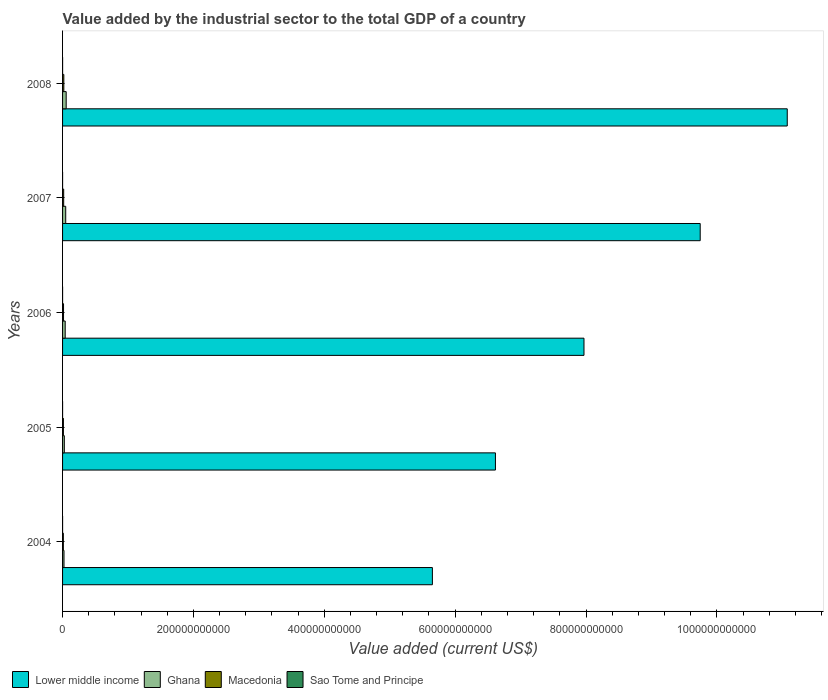Are the number of bars per tick equal to the number of legend labels?
Keep it short and to the point. Yes. How many bars are there on the 4th tick from the top?
Ensure brevity in your answer.  4. How many bars are there on the 4th tick from the bottom?
Ensure brevity in your answer.  4. What is the label of the 3rd group of bars from the top?
Make the answer very short. 2006. In how many cases, is the number of bars for a given year not equal to the number of legend labels?
Your response must be concise. 0. What is the value added by the industrial sector to the total GDP in Macedonia in 2006?
Offer a very short reply. 1.49e+09. Across all years, what is the maximum value added by the industrial sector to the total GDP in Ghana?
Make the answer very short. 5.53e+09. Across all years, what is the minimum value added by the industrial sector to the total GDP in Ghana?
Offer a very short reply. 2.20e+09. What is the total value added by the industrial sector to the total GDP in Ghana in the graph?
Make the answer very short. 1.93e+1. What is the difference between the value added by the industrial sector to the total GDP in Lower middle income in 2004 and that in 2007?
Your answer should be very brief. -4.09e+11. What is the difference between the value added by the industrial sector to the total GDP in Lower middle income in 2004 and the value added by the industrial sector to the total GDP in Macedonia in 2007?
Provide a short and direct response. 5.63e+11. What is the average value added by the industrial sector to the total GDP in Sao Tome and Principe per year?
Provide a short and direct response. 2.18e+07. In the year 2005, what is the difference between the value added by the industrial sector to the total GDP in Ghana and value added by the industrial sector to the total GDP in Macedonia?
Keep it short and to the point. 1.42e+09. What is the ratio of the value added by the industrial sector to the total GDP in Lower middle income in 2005 to that in 2006?
Give a very brief answer. 0.83. Is the value added by the industrial sector to the total GDP in Sao Tome and Principe in 2004 less than that in 2008?
Keep it short and to the point. Yes. Is the difference between the value added by the industrial sector to the total GDP in Ghana in 2005 and 2008 greater than the difference between the value added by the industrial sector to the total GDP in Macedonia in 2005 and 2008?
Make the answer very short. No. What is the difference between the highest and the second highest value added by the industrial sector to the total GDP in Sao Tome and Principe?
Provide a succinct answer. 1.04e+07. What is the difference between the highest and the lowest value added by the industrial sector to the total GDP in Macedonia?
Provide a short and direct response. 7.40e+08. Is the sum of the value added by the industrial sector to the total GDP in Macedonia in 2005 and 2006 greater than the maximum value added by the industrial sector to the total GDP in Ghana across all years?
Offer a terse response. No. Is it the case that in every year, the sum of the value added by the industrial sector to the total GDP in Lower middle income and value added by the industrial sector to the total GDP in Sao Tome and Principe is greater than the sum of value added by the industrial sector to the total GDP in Ghana and value added by the industrial sector to the total GDP in Macedonia?
Offer a terse response. Yes. What does the 1st bar from the top in 2006 represents?
Ensure brevity in your answer.  Sao Tome and Principe. What does the 1st bar from the bottom in 2005 represents?
Your answer should be very brief. Lower middle income. Is it the case that in every year, the sum of the value added by the industrial sector to the total GDP in Lower middle income and value added by the industrial sector to the total GDP in Macedonia is greater than the value added by the industrial sector to the total GDP in Sao Tome and Principe?
Your answer should be compact. Yes. What is the difference between two consecutive major ticks on the X-axis?
Provide a succinct answer. 2.00e+11. Are the values on the major ticks of X-axis written in scientific E-notation?
Make the answer very short. No. Does the graph contain any zero values?
Offer a terse response. No. Does the graph contain grids?
Keep it short and to the point. No. How are the legend labels stacked?
Provide a short and direct response. Horizontal. What is the title of the graph?
Your answer should be compact. Value added by the industrial sector to the total GDP of a country. Does "Saudi Arabia" appear as one of the legend labels in the graph?
Provide a succinct answer. No. What is the label or title of the X-axis?
Your answer should be very brief. Value added (current US$). What is the label or title of the Y-axis?
Your answer should be compact. Years. What is the Value added (current US$) of Lower middle income in 2004?
Offer a terse response. 5.65e+11. What is the Value added (current US$) of Ghana in 2004?
Keep it short and to the point. 2.20e+09. What is the Value added (current US$) in Macedonia in 2004?
Ensure brevity in your answer.  1.20e+09. What is the Value added (current US$) in Sao Tome and Principe in 2004?
Ensure brevity in your answer.  1.64e+07. What is the Value added (current US$) in Lower middle income in 2005?
Offer a terse response. 6.62e+11. What is the Value added (current US$) of Ghana in 2005?
Provide a short and direct response. 2.70e+09. What is the Value added (current US$) of Macedonia in 2005?
Your response must be concise. 1.27e+09. What is the Value added (current US$) in Sao Tome and Principe in 2005?
Your answer should be compact. 1.89e+07. What is the Value added (current US$) in Lower middle income in 2006?
Ensure brevity in your answer.  7.97e+11. What is the Value added (current US$) of Ghana in 2006?
Keep it short and to the point. 4.04e+09. What is the Value added (current US$) in Macedonia in 2006?
Provide a succinct answer. 1.49e+09. What is the Value added (current US$) of Sao Tome and Principe in 2006?
Your answer should be very brief. 1.98e+07. What is the Value added (current US$) in Lower middle income in 2007?
Provide a short and direct response. 9.75e+11. What is the Value added (current US$) of Ghana in 2007?
Give a very brief answer. 4.83e+09. What is the Value added (current US$) of Macedonia in 2007?
Ensure brevity in your answer.  1.72e+09. What is the Value added (current US$) of Sao Tome and Principe in 2007?
Your response must be concise. 2.17e+07. What is the Value added (current US$) in Lower middle income in 2008?
Offer a terse response. 1.11e+12. What is the Value added (current US$) in Ghana in 2008?
Offer a very short reply. 5.53e+09. What is the Value added (current US$) in Macedonia in 2008?
Ensure brevity in your answer.  1.94e+09. What is the Value added (current US$) of Sao Tome and Principe in 2008?
Your response must be concise. 3.22e+07. Across all years, what is the maximum Value added (current US$) in Lower middle income?
Your answer should be compact. 1.11e+12. Across all years, what is the maximum Value added (current US$) of Ghana?
Offer a terse response. 5.53e+09. Across all years, what is the maximum Value added (current US$) of Macedonia?
Your answer should be compact. 1.94e+09. Across all years, what is the maximum Value added (current US$) of Sao Tome and Principe?
Keep it short and to the point. 3.22e+07. Across all years, what is the minimum Value added (current US$) in Lower middle income?
Your answer should be compact. 5.65e+11. Across all years, what is the minimum Value added (current US$) of Ghana?
Offer a very short reply. 2.20e+09. Across all years, what is the minimum Value added (current US$) of Macedonia?
Make the answer very short. 1.20e+09. Across all years, what is the minimum Value added (current US$) in Sao Tome and Principe?
Offer a terse response. 1.64e+07. What is the total Value added (current US$) in Lower middle income in the graph?
Your response must be concise. 4.11e+12. What is the total Value added (current US$) in Ghana in the graph?
Keep it short and to the point. 1.93e+1. What is the total Value added (current US$) of Macedonia in the graph?
Provide a short and direct response. 7.61e+09. What is the total Value added (current US$) of Sao Tome and Principe in the graph?
Ensure brevity in your answer.  1.09e+08. What is the difference between the Value added (current US$) in Lower middle income in 2004 and that in 2005?
Make the answer very short. -9.64e+1. What is the difference between the Value added (current US$) of Ghana in 2004 and that in 2005?
Your answer should be very brief. -5.01e+08. What is the difference between the Value added (current US$) in Macedonia in 2004 and that in 2005?
Give a very brief answer. -7.88e+07. What is the difference between the Value added (current US$) in Sao Tome and Principe in 2004 and that in 2005?
Your response must be concise. -2.54e+06. What is the difference between the Value added (current US$) in Lower middle income in 2004 and that in 2006?
Provide a short and direct response. -2.32e+11. What is the difference between the Value added (current US$) in Ghana in 2004 and that in 2006?
Your answer should be very brief. -1.85e+09. What is the difference between the Value added (current US$) of Macedonia in 2004 and that in 2006?
Your answer should be very brief. -2.91e+08. What is the difference between the Value added (current US$) in Sao Tome and Principe in 2004 and that in 2006?
Your answer should be very brief. -3.43e+06. What is the difference between the Value added (current US$) of Lower middle income in 2004 and that in 2007?
Offer a terse response. -4.09e+11. What is the difference between the Value added (current US$) of Ghana in 2004 and that in 2007?
Your answer should be very brief. -2.63e+09. What is the difference between the Value added (current US$) in Macedonia in 2004 and that in 2007?
Offer a terse response. -5.20e+08. What is the difference between the Value added (current US$) in Sao Tome and Principe in 2004 and that in 2007?
Give a very brief answer. -5.34e+06. What is the difference between the Value added (current US$) in Lower middle income in 2004 and that in 2008?
Your answer should be compact. -5.42e+11. What is the difference between the Value added (current US$) of Ghana in 2004 and that in 2008?
Provide a short and direct response. -3.34e+09. What is the difference between the Value added (current US$) of Macedonia in 2004 and that in 2008?
Provide a succinct answer. -7.40e+08. What is the difference between the Value added (current US$) in Sao Tome and Principe in 2004 and that in 2008?
Your answer should be very brief. -1.58e+07. What is the difference between the Value added (current US$) in Lower middle income in 2005 and that in 2006?
Provide a succinct answer. -1.35e+11. What is the difference between the Value added (current US$) in Ghana in 2005 and that in 2006?
Provide a succinct answer. -1.35e+09. What is the difference between the Value added (current US$) in Macedonia in 2005 and that in 2006?
Ensure brevity in your answer.  -2.12e+08. What is the difference between the Value added (current US$) of Sao Tome and Principe in 2005 and that in 2006?
Provide a succinct answer. -8.85e+05. What is the difference between the Value added (current US$) of Lower middle income in 2005 and that in 2007?
Your response must be concise. -3.13e+11. What is the difference between the Value added (current US$) in Ghana in 2005 and that in 2007?
Provide a succinct answer. -2.13e+09. What is the difference between the Value added (current US$) in Macedonia in 2005 and that in 2007?
Provide a succinct answer. -4.41e+08. What is the difference between the Value added (current US$) in Sao Tome and Principe in 2005 and that in 2007?
Provide a succinct answer. -2.80e+06. What is the difference between the Value added (current US$) of Lower middle income in 2005 and that in 2008?
Ensure brevity in your answer.  -4.46e+11. What is the difference between the Value added (current US$) of Ghana in 2005 and that in 2008?
Your answer should be very brief. -2.84e+09. What is the difference between the Value added (current US$) in Macedonia in 2005 and that in 2008?
Provide a succinct answer. -6.61e+08. What is the difference between the Value added (current US$) of Sao Tome and Principe in 2005 and that in 2008?
Provide a succinct answer. -1.32e+07. What is the difference between the Value added (current US$) of Lower middle income in 2006 and that in 2007?
Provide a succinct answer. -1.78e+11. What is the difference between the Value added (current US$) in Ghana in 2006 and that in 2007?
Give a very brief answer. -7.84e+08. What is the difference between the Value added (current US$) in Macedonia in 2006 and that in 2007?
Provide a short and direct response. -2.29e+08. What is the difference between the Value added (current US$) in Sao Tome and Principe in 2006 and that in 2007?
Your answer should be very brief. -1.92e+06. What is the difference between the Value added (current US$) of Lower middle income in 2006 and that in 2008?
Keep it short and to the point. -3.11e+11. What is the difference between the Value added (current US$) of Ghana in 2006 and that in 2008?
Your answer should be very brief. -1.49e+09. What is the difference between the Value added (current US$) of Macedonia in 2006 and that in 2008?
Ensure brevity in your answer.  -4.49e+08. What is the difference between the Value added (current US$) of Sao Tome and Principe in 2006 and that in 2008?
Your answer should be compact. -1.24e+07. What is the difference between the Value added (current US$) in Lower middle income in 2007 and that in 2008?
Your answer should be compact. -1.33e+11. What is the difference between the Value added (current US$) in Ghana in 2007 and that in 2008?
Provide a succinct answer. -7.08e+08. What is the difference between the Value added (current US$) of Macedonia in 2007 and that in 2008?
Give a very brief answer. -2.20e+08. What is the difference between the Value added (current US$) in Sao Tome and Principe in 2007 and that in 2008?
Ensure brevity in your answer.  -1.04e+07. What is the difference between the Value added (current US$) in Lower middle income in 2004 and the Value added (current US$) in Ghana in 2005?
Your answer should be very brief. 5.63e+11. What is the difference between the Value added (current US$) in Lower middle income in 2004 and the Value added (current US$) in Macedonia in 2005?
Your answer should be compact. 5.64e+11. What is the difference between the Value added (current US$) of Lower middle income in 2004 and the Value added (current US$) of Sao Tome and Principe in 2005?
Provide a short and direct response. 5.65e+11. What is the difference between the Value added (current US$) of Ghana in 2004 and the Value added (current US$) of Macedonia in 2005?
Provide a short and direct response. 9.21e+08. What is the difference between the Value added (current US$) in Ghana in 2004 and the Value added (current US$) in Sao Tome and Principe in 2005?
Your answer should be very brief. 2.18e+09. What is the difference between the Value added (current US$) of Macedonia in 2004 and the Value added (current US$) of Sao Tome and Principe in 2005?
Provide a succinct answer. 1.18e+09. What is the difference between the Value added (current US$) of Lower middle income in 2004 and the Value added (current US$) of Ghana in 2006?
Keep it short and to the point. 5.61e+11. What is the difference between the Value added (current US$) of Lower middle income in 2004 and the Value added (current US$) of Macedonia in 2006?
Your response must be concise. 5.64e+11. What is the difference between the Value added (current US$) of Lower middle income in 2004 and the Value added (current US$) of Sao Tome and Principe in 2006?
Give a very brief answer. 5.65e+11. What is the difference between the Value added (current US$) of Ghana in 2004 and the Value added (current US$) of Macedonia in 2006?
Offer a terse response. 7.09e+08. What is the difference between the Value added (current US$) in Ghana in 2004 and the Value added (current US$) in Sao Tome and Principe in 2006?
Provide a short and direct response. 2.18e+09. What is the difference between the Value added (current US$) in Macedonia in 2004 and the Value added (current US$) in Sao Tome and Principe in 2006?
Give a very brief answer. 1.18e+09. What is the difference between the Value added (current US$) of Lower middle income in 2004 and the Value added (current US$) of Ghana in 2007?
Your response must be concise. 5.60e+11. What is the difference between the Value added (current US$) of Lower middle income in 2004 and the Value added (current US$) of Macedonia in 2007?
Provide a short and direct response. 5.63e+11. What is the difference between the Value added (current US$) in Lower middle income in 2004 and the Value added (current US$) in Sao Tome and Principe in 2007?
Offer a terse response. 5.65e+11. What is the difference between the Value added (current US$) in Ghana in 2004 and the Value added (current US$) in Macedonia in 2007?
Make the answer very short. 4.79e+08. What is the difference between the Value added (current US$) of Ghana in 2004 and the Value added (current US$) of Sao Tome and Principe in 2007?
Offer a very short reply. 2.17e+09. What is the difference between the Value added (current US$) of Macedonia in 2004 and the Value added (current US$) of Sao Tome and Principe in 2007?
Offer a very short reply. 1.17e+09. What is the difference between the Value added (current US$) of Lower middle income in 2004 and the Value added (current US$) of Ghana in 2008?
Offer a very short reply. 5.60e+11. What is the difference between the Value added (current US$) of Lower middle income in 2004 and the Value added (current US$) of Macedonia in 2008?
Ensure brevity in your answer.  5.63e+11. What is the difference between the Value added (current US$) of Lower middle income in 2004 and the Value added (current US$) of Sao Tome and Principe in 2008?
Give a very brief answer. 5.65e+11. What is the difference between the Value added (current US$) of Ghana in 2004 and the Value added (current US$) of Macedonia in 2008?
Offer a very short reply. 2.60e+08. What is the difference between the Value added (current US$) in Ghana in 2004 and the Value added (current US$) in Sao Tome and Principe in 2008?
Ensure brevity in your answer.  2.16e+09. What is the difference between the Value added (current US$) in Macedonia in 2004 and the Value added (current US$) in Sao Tome and Principe in 2008?
Make the answer very short. 1.16e+09. What is the difference between the Value added (current US$) in Lower middle income in 2005 and the Value added (current US$) in Ghana in 2006?
Your answer should be compact. 6.58e+11. What is the difference between the Value added (current US$) in Lower middle income in 2005 and the Value added (current US$) in Macedonia in 2006?
Give a very brief answer. 6.60e+11. What is the difference between the Value added (current US$) in Lower middle income in 2005 and the Value added (current US$) in Sao Tome and Principe in 2006?
Provide a short and direct response. 6.62e+11. What is the difference between the Value added (current US$) of Ghana in 2005 and the Value added (current US$) of Macedonia in 2006?
Offer a very short reply. 1.21e+09. What is the difference between the Value added (current US$) in Ghana in 2005 and the Value added (current US$) in Sao Tome and Principe in 2006?
Keep it short and to the point. 2.68e+09. What is the difference between the Value added (current US$) in Macedonia in 2005 and the Value added (current US$) in Sao Tome and Principe in 2006?
Your answer should be very brief. 1.25e+09. What is the difference between the Value added (current US$) in Lower middle income in 2005 and the Value added (current US$) in Ghana in 2007?
Your response must be concise. 6.57e+11. What is the difference between the Value added (current US$) of Lower middle income in 2005 and the Value added (current US$) of Macedonia in 2007?
Make the answer very short. 6.60e+11. What is the difference between the Value added (current US$) of Lower middle income in 2005 and the Value added (current US$) of Sao Tome and Principe in 2007?
Offer a terse response. 6.62e+11. What is the difference between the Value added (current US$) in Ghana in 2005 and the Value added (current US$) in Macedonia in 2007?
Ensure brevity in your answer.  9.81e+08. What is the difference between the Value added (current US$) in Ghana in 2005 and the Value added (current US$) in Sao Tome and Principe in 2007?
Ensure brevity in your answer.  2.67e+09. What is the difference between the Value added (current US$) in Macedonia in 2005 and the Value added (current US$) in Sao Tome and Principe in 2007?
Your answer should be very brief. 1.25e+09. What is the difference between the Value added (current US$) in Lower middle income in 2005 and the Value added (current US$) in Ghana in 2008?
Your answer should be very brief. 6.56e+11. What is the difference between the Value added (current US$) of Lower middle income in 2005 and the Value added (current US$) of Macedonia in 2008?
Provide a short and direct response. 6.60e+11. What is the difference between the Value added (current US$) in Lower middle income in 2005 and the Value added (current US$) in Sao Tome and Principe in 2008?
Your answer should be compact. 6.62e+11. What is the difference between the Value added (current US$) in Ghana in 2005 and the Value added (current US$) in Macedonia in 2008?
Your answer should be compact. 7.61e+08. What is the difference between the Value added (current US$) of Ghana in 2005 and the Value added (current US$) of Sao Tome and Principe in 2008?
Make the answer very short. 2.66e+09. What is the difference between the Value added (current US$) in Macedonia in 2005 and the Value added (current US$) in Sao Tome and Principe in 2008?
Provide a short and direct response. 1.24e+09. What is the difference between the Value added (current US$) in Lower middle income in 2006 and the Value added (current US$) in Ghana in 2007?
Your answer should be very brief. 7.92e+11. What is the difference between the Value added (current US$) of Lower middle income in 2006 and the Value added (current US$) of Macedonia in 2007?
Your response must be concise. 7.95e+11. What is the difference between the Value added (current US$) of Lower middle income in 2006 and the Value added (current US$) of Sao Tome and Principe in 2007?
Ensure brevity in your answer.  7.97e+11. What is the difference between the Value added (current US$) in Ghana in 2006 and the Value added (current US$) in Macedonia in 2007?
Give a very brief answer. 2.33e+09. What is the difference between the Value added (current US$) of Ghana in 2006 and the Value added (current US$) of Sao Tome and Principe in 2007?
Offer a very short reply. 4.02e+09. What is the difference between the Value added (current US$) of Macedonia in 2006 and the Value added (current US$) of Sao Tome and Principe in 2007?
Keep it short and to the point. 1.46e+09. What is the difference between the Value added (current US$) of Lower middle income in 2006 and the Value added (current US$) of Ghana in 2008?
Provide a succinct answer. 7.91e+11. What is the difference between the Value added (current US$) of Lower middle income in 2006 and the Value added (current US$) of Macedonia in 2008?
Give a very brief answer. 7.95e+11. What is the difference between the Value added (current US$) in Lower middle income in 2006 and the Value added (current US$) in Sao Tome and Principe in 2008?
Ensure brevity in your answer.  7.97e+11. What is the difference between the Value added (current US$) in Ghana in 2006 and the Value added (current US$) in Macedonia in 2008?
Ensure brevity in your answer.  2.11e+09. What is the difference between the Value added (current US$) in Ghana in 2006 and the Value added (current US$) in Sao Tome and Principe in 2008?
Provide a succinct answer. 4.01e+09. What is the difference between the Value added (current US$) of Macedonia in 2006 and the Value added (current US$) of Sao Tome and Principe in 2008?
Offer a very short reply. 1.45e+09. What is the difference between the Value added (current US$) in Lower middle income in 2007 and the Value added (current US$) in Ghana in 2008?
Your response must be concise. 9.69e+11. What is the difference between the Value added (current US$) of Lower middle income in 2007 and the Value added (current US$) of Macedonia in 2008?
Make the answer very short. 9.73e+11. What is the difference between the Value added (current US$) in Lower middle income in 2007 and the Value added (current US$) in Sao Tome and Principe in 2008?
Offer a terse response. 9.74e+11. What is the difference between the Value added (current US$) in Ghana in 2007 and the Value added (current US$) in Macedonia in 2008?
Your response must be concise. 2.89e+09. What is the difference between the Value added (current US$) of Ghana in 2007 and the Value added (current US$) of Sao Tome and Principe in 2008?
Ensure brevity in your answer.  4.79e+09. What is the difference between the Value added (current US$) of Macedonia in 2007 and the Value added (current US$) of Sao Tome and Principe in 2008?
Give a very brief answer. 1.68e+09. What is the average Value added (current US$) in Lower middle income per year?
Give a very brief answer. 8.21e+11. What is the average Value added (current US$) in Ghana per year?
Give a very brief answer. 3.86e+09. What is the average Value added (current US$) of Macedonia per year?
Offer a terse response. 1.52e+09. What is the average Value added (current US$) of Sao Tome and Principe per year?
Keep it short and to the point. 2.18e+07. In the year 2004, what is the difference between the Value added (current US$) in Lower middle income and Value added (current US$) in Ghana?
Keep it short and to the point. 5.63e+11. In the year 2004, what is the difference between the Value added (current US$) of Lower middle income and Value added (current US$) of Macedonia?
Ensure brevity in your answer.  5.64e+11. In the year 2004, what is the difference between the Value added (current US$) of Lower middle income and Value added (current US$) of Sao Tome and Principe?
Your response must be concise. 5.65e+11. In the year 2004, what is the difference between the Value added (current US$) in Ghana and Value added (current US$) in Macedonia?
Provide a succinct answer. 1.00e+09. In the year 2004, what is the difference between the Value added (current US$) of Ghana and Value added (current US$) of Sao Tome and Principe?
Provide a short and direct response. 2.18e+09. In the year 2004, what is the difference between the Value added (current US$) of Macedonia and Value added (current US$) of Sao Tome and Principe?
Provide a short and direct response. 1.18e+09. In the year 2005, what is the difference between the Value added (current US$) of Lower middle income and Value added (current US$) of Ghana?
Make the answer very short. 6.59e+11. In the year 2005, what is the difference between the Value added (current US$) of Lower middle income and Value added (current US$) of Macedonia?
Ensure brevity in your answer.  6.60e+11. In the year 2005, what is the difference between the Value added (current US$) of Lower middle income and Value added (current US$) of Sao Tome and Principe?
Your answer should be compact. 6.62e+11. In the year 2005, what is the difference between the Value added (current US$) of Ghana and Value added (current US$) of Macedonia?
Ensure brevity in your answer.  1.42e+09. In the year 2005, what is the difference between the Value added (current US$) of Ghana and Value added (current US$) of Sao Tome and Principe?
Your answer should be compact. 2.68e+09. In the year 2005, what is the difference between the Value added (current US$) in Macedonia and Value added (current US$) in Sao Tome and Principe?
Ensure brevity in your answer.  1.26e+09. In the year 2006, what is the difference between the Value added (current US$) in Lower middle income and Value added (current US$) in Ghana?
Make the answer very short. 7.93e+11. In the year 2006, what is the difference between the Value added (current US$) of Lower middle income and Value added (current US$) of Macedonia?
Keep it short and to the point. 7.95e+11. In the year 2006, what is the difference between the Value added (current US$) of Lower middle income and Value added (current US$) of Sao Tome and Principe?
Give a very brief answer. 7.97e+11. In the year 2006, what is the difference between the Value added (current US$) of Ghana and Value added (current US$) of Macedonia?
Your answer should be very brief. 2.56e+09. In the year 2006, what is the difference between the Value added (current US$) in Ghana and Value added (current US$) in Sao Tome and Principe?
Your response must be concise. 4.02e+09. In the year 2006, what is the difference between the Value added (current US$) of Macedonia and Value added (current US$) of Sao Tome and Principe?
Your answer should be very brief. 1.47e+09. In the year 2007, what is the difference between the Value added (current US$) of Lower middle income and Value added (current US$) of Ghana?
Give a very brief answer. 9.70e+11. In the year 2007, what is the difference between the Value added (current US$) in Lower middle income and Value added (current US$) in Macedonia?
Offer a very short reply. 9.73e+11. In the year 2007, what is the difference between the Value added (current US$) in Lower middle income and Value added (current US$) in Sao Tome and Principe?
Ensure brevity in your answer.  9.75e+11. In the year 2007, what is the difference between the Value added (current US$) in Ghana and Value added (current US$) in Macedonia?
Your answer should be compact. 3.11e+09. In the year 2007, what is the difference between the Value added (current US$) of Ghana and Value added (current US$) of Sao Tome and Principe?
Provide a short and direct response. 4.80e+09. In the year 2007, what is the difference between the Value added (current US$) in Macedonia and Value added (current US$) in Sao Tome and Principe?
Keep it short and to the point. 1.69e+09. In the year 2008, what is the difference between the Value added (current US$) of Lower middle income and Value added (current US$) of Ghana?
Your response must be concise. 1.10e+12. In the year 2008, what is the difference between the Value added (current US$) of Lower middle income and Value added (current US$) of Macedonia?
Make the answer very short. 1.11e+12. In the year 2008, what is the difference between the Value added (current US$) of Lower middle income and Value added (current US$) of Sao Tome and Principe?
Offer a very short reply. 1.11e+12. In the year 2008, what is the difference between the Value added (current US$) of Ghana and Value added (current US$) of Macedonia?
Keep it short and to the point. 3.60e+09. In the year 2008, what is the difference between the Value added (current US$) in Ghana and Value added (current US$) in Sao Tome and Principe?
Make the answer very short. 5.50e+09. In the year 2008, what is the difference between the Value added (current US$) in Macedonia and Value added (current US$) in Sao Tome and Principe?
Give a very brief answer. 1.90e+09. What is the ratio of the Value added (current US$) of Lower middle income in 2004 to that in 2005?
Make the answer very short. 0.85. What is the ratio of the Value added (current US$) in Ghana in 2004 to that in 2005?
Provide a succinct answer. 0.81. What is the ratio of the Value added (current US$) of Macedonia in 2004 to that in 2005?
Offer a very short reply. 0.94. What is the ratio of the Value added (current US$) of Sao Tome and Principe in 2004 to that in 2005?
Your response must be concise. 0.87. What is the ratio of the Value added (current US$) in Lower middle income in 2004 to that in 2006?
Provide a succinct answer. 0.71. What is the ratio of the Value added (current US$) in Ghana in 2004 to that in 2006?
Provide a succinct answer. 0.54. What is the ratio of the Value added (current US$) in Macedonia in 2004 to that in 2006?
Provide a succinct answer. 0.8. What is the ratio of the Value added (current US$) in Sao Tome and Principe in 2004 to that in 2006?
Your answer should be compact. 0.83. What is the ratio of the Value added (current US$) of Lower middle income in 2004 to that in 2007?
Offer a very short reply. 0.58. What is the ratio of the Value added (current US$) in Ghana in 2004 to that in 2007?
Offer a very short reply. 0.45. What is the ratio of the Value added (current US$) of Macedonia in 2004 to that in 2007?
Your response must be concise. 0.7. What is the ratio of the Value added (current US$) of Sao Tome and Principe in 2004 to that in 2007?
Give a very brief answer. 0.75. What is the ratio of the Value added (current US$) in Lower middle income in 2004 to that in 2008?
Make the answer very short. 0.51. What is the ratio of the Value added (current US$) of Ghana in 2004 to that in 2008?
Your answer should be very brief. 0.4. What is the ratio of the Value added (current US$) of Macedonia in 2004 to that in 2008?
Make the answer very short. 0.62. What is the ratio of the Value added (current US$) in Sao Tome and Principe in 2004 to that in 2008?
Provide a succinct answer. 0.51. What is the ratio of the Value added (current US$) of Lower middle income in 2005 to that in 2006?
Ensure brevity in your answer.  0.83. What is the ratio of the Value added (current US$) of Ghana in 2005 to that in 2006?
Offer a terse response. 0.67. What is the ratio of the Value added (current US$) in Macedonia in 2005 to that in 2006?
Your answer should be compact. 0.86. What is the ratio of the Value added (current US$) of Sao Tome and Principe in 2005 to that in 2006?
Keep it short and to the point. 0.96. What is the ratio of the Value added (current US$) of Lower middle income in 2005 to that in 2007?
Offer a terse response. 0.68. What is the ratio of the Value added (current US$) in Ghana in 2005 to that in 2007?
Keep it short and to the point. 0.56. What is the ratio of the Value added (current US$) in Macedonia in 2005 to that in 2007?
Provide a short and direct response. 0.74. What is the ratio of the Value added (current US$) in Sao Tome and Principe in 2005 to that in 2007?
Your response must be concise. 0.87. What is the ratio of the Value added (current US$) of Lower middle income in 2005 to that in 2008?
Offer a terse response. 0.6. What is the ratio of the Value added (current US$) in Ghana in 2005 to that in 2008?
Your answer should be very brief. 0.49. What is the ratio of the Value added (current US$) of Macedonia in 2005 to that in 2008?
Offer a terse response. 0.66. What is the ratio of the Value added (current US$) of Sao Tome and Principe in 2005 to that in 2008?
Your answer should be very brief. 0.59. What is the ratio of the Value added (current US$) in Lower middle income in 2006 to that in 2007?
Make the answer very short. 0.82. What is the ratio of the Value added (current US$) of Ghana in 2006 to that in 2007?
Ensure brevity in your answer.  0.84. What is the ratio of the Value added (current US$) of Macedonia in 2006 to that in 2007?
Offer a very short reply. 0.87. What is the ratio of the Value added (current US$) in Sao Tome and Principe in 2006 to that in 2007?
Offer a very short reply. 0.91. What is the ratio of the Value added (current US$) of Lower middle income in 2006 to that in 2008?
Offer a very short reply. 0.72. What is the ratio of the Value added (current US$) in Ghana in 2006 to that in 2008?
Your response must be concise. 0.73. What is the ratio of the Value added (current US$) of Macedonia in 2006 to that in 2008?
Make the answer very short. 0.77. What is the ratio of the Value added (current US$) in Sao Tome and Principe in 2006 to that in 2008?
Your answer should be very brief. 0.62. What is the ratio of the Value added (current US$) in Lower middle income in 2007 to that in 2008?
Offer a very short reply. 0.88. What is the ratio of the Value added (current US$) in Ghana in 2007 to that in 2008?
Offer a terse response. 0.87. What is the ratio of the Value added (current US$) in Macedonia in 2007 to that in 2008?
Make the answer very short. 0.89. What is the ratio of the Value added (current US$) of Sao Tome and Principe in 2007 to that in 2008?
Make the answer very short. 0.68. What is the difference between the highest and the second highest Value added (current US$) of Lower middle income?
Keep it short and to the point. 1.33e+11. What is the difference between the highest and the second highest Value added (current US$) in Ghana?
Make the answer very short. 7.08e+08. What is the difference between the highest and the second highest Value added (current US$) in Macedonia?
Your answer should be very brief. 2.20e+08. What is the difference between the highest and the second highest Value added (current US$) of Sao Tome and Principe?
Ensure brevity in your answer.  1.04e+07. What is the difference between the highest and the lowest Value added (current US$) in Lower middle income?
Make the answer very short. 5.42e+11. What is the difference between the highest and the lowest Value added (current US$) of Ghana?
Provide a short and direct response. 3.34e+09. What is the difference between the highest and the lowest Value added (current US$) in Macedonia?
Your answer should be very brief. 7.40e+08. What is the difference between the highest and the lowest Value added (current US$) of Sao Tome and Principe?
Keep it short and to the point. 1.58e+07. 